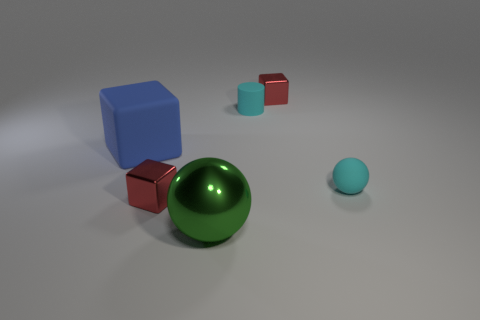Add 4 red cubes. How many objects exist? 10 Subtract all spheres. How many objects are left? 4 Add 4 cylinders. How many cylinders are left? 5 Add 6 large green spheres. How many large green spheres exist? 7 Subtract 0 yellow blocks. How many objects are left? 6 Subtract all small cyan objects. Subtract all tiny spheres. How many objects are left? 3 